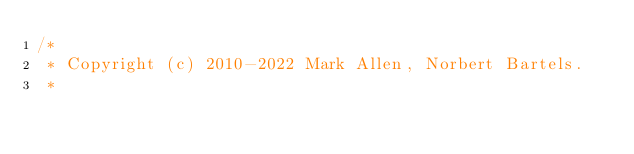Convert code to text. <code><loc_0><loc_0><loc_500><loc_500><_Java_>/*
 * Copyright (c) 2010-2022 Mark Allen, Norbert Bartels.
 *</code> 